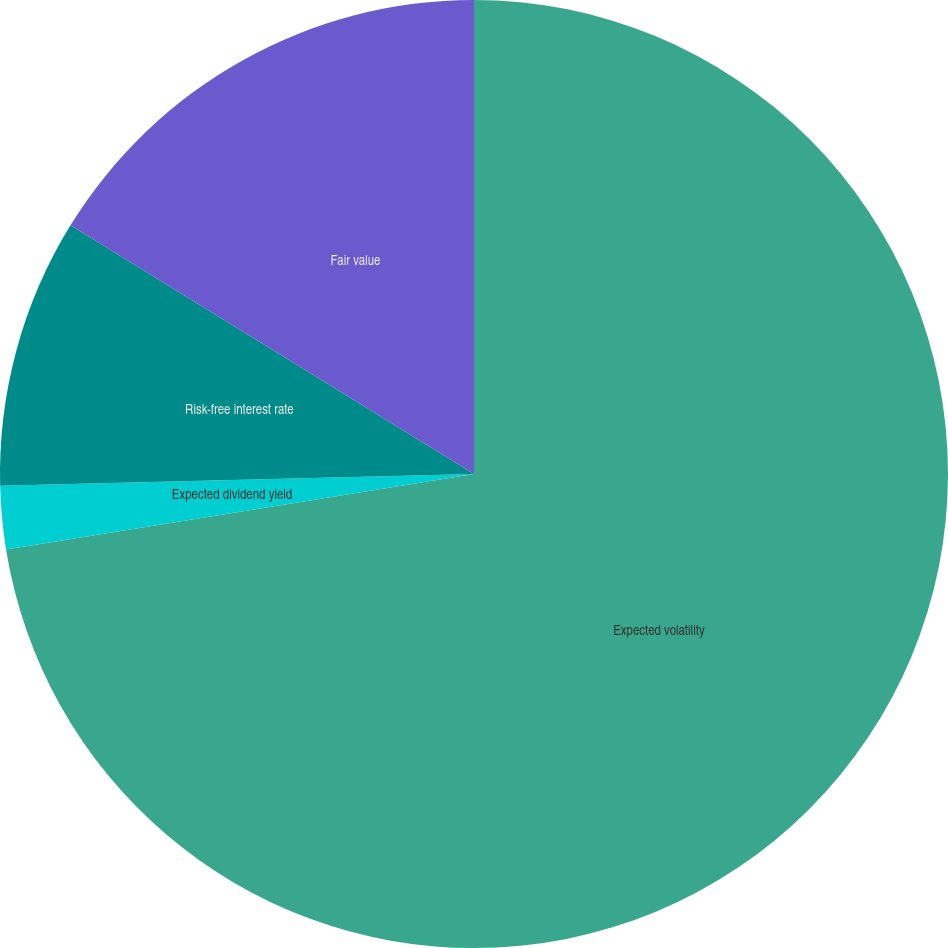<chart> <loc_0><loc_0><loc_500><loc_500><pie_chart><fcel>Expected volatility<fcel>Expected dividend yield<fcel>Risk-free interest rate<fcel>Fair value<nl><fcel>72.45%<fcel>2.15%<fcel>9.18%<fcel>16.21%<nl></chart> 